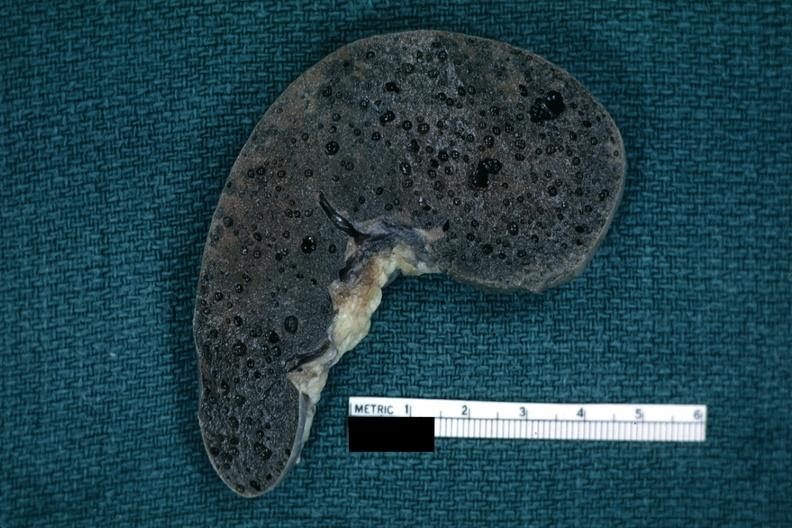does chronic ischemia show fixed tissue typical swiss cheese appearance of tissue with this artefact?
Answer the question using a single word or phrase. No 